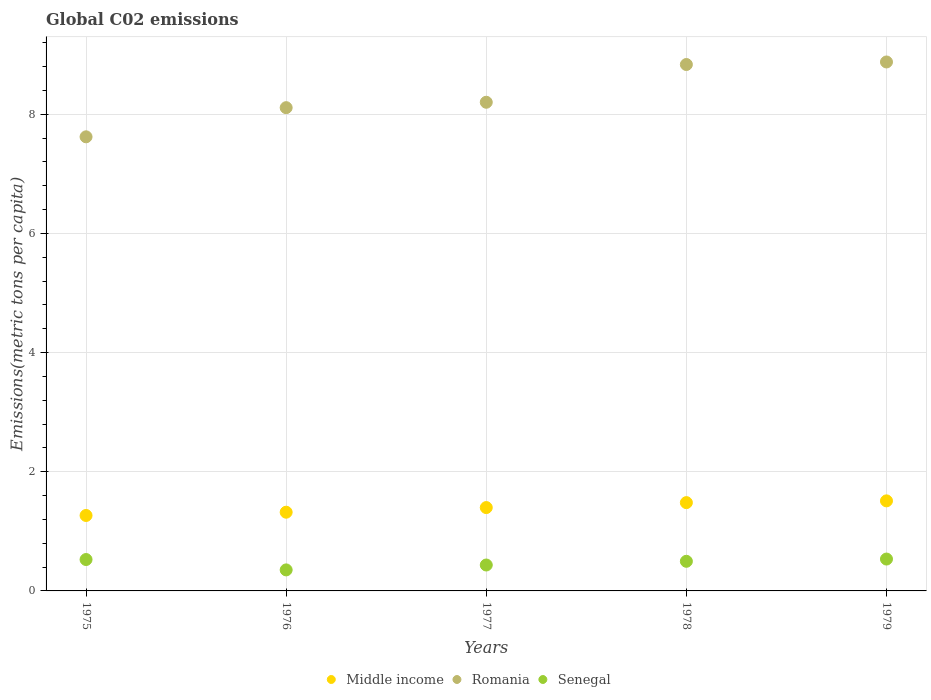How many different coloured dotlines are there?
Ensure brevity in your answer.  3. Is the number of dotlines equal to the number of legend labels?
Ensure brevity in your answer.  Yes. What is the amount of CO2 emitted in in Romania in 1979?
Your response must be concise. 8.88. Across all years, what is the maximum amount of CO2 emitted in in Middle income?
Provide a short and direct response. 1.51. Across all years, what is the minimum amount of CO2 emitted in in Senegal?
Make the answer very short. 0.35. In which year was the amount of CO2 emitted in in Middle income maximum?
Your answer should be compact. 1979. In which year was the amount of CO2 emitted in in Romania minimum?
Your answer should be compact. 1975. What is the total amount of CO2 emitted in in Senegal in the graph?
Provide a short and direct response. 2.35. What is the difference between the amount of CO2 emitted in in Romania in 1976 and that in 1977?
Ensure brevity in your answer.  -0.09. What is the difference between the amount of CO2 emitted in in Romania in 1979 and the amount of CO2 emitted in in Senegal in 1975?
Give a very brief answer. 8.35. What is the average amount of CO2 emitted in in Senegal per year?
Offer a very short reply. 0.47. In the year 1976, what is the difference between the amount of CO2 emitted in in Middle income and amount of CO2 emitted in in Senegal?
Keep it short and to the point. 0.97. What is the ratio of the amount of CO2 emitted in in Middle income in 1975 to that in 1977?
Provide a succinct answer. 0.91. What is the difference between the highest and the second highest amount of CO2 emitted in in Senegal?
Give a very brief answer. 0.01. What is the difference between the highest and the lowest amount of CO2 emitted in in Middle income?
Provide a short and direct response. 0.25. In how many years, is the amount of CO2 emitted in in Romania greater than the average amount of CO2 emitted in in Romania taken over all years?
Your answer should be compact. 2. Is the sum of the amount of CO2 emitted in in Romania in 1975 and 1978 greater than the maximum amount of CO2 emitted in in Senegal across all years?
Keep it short and to the point. Yes. Does the amount of CO2 emitted in in Senegal monotonically increase over the years?
Ensure brevity in your answer.  No. Is the amount of CO2 emitted in in Middle income strictly greater than the amount of CO2 emitted in in Romania over the years?
Ensure brevity in your answer.  No. How many dotlines are there?
Your answer should be very brief. 3. How many years are there in the graph?
Provide a succinct answer. 5. Are the values on the major ticks of Y-axis written in scientific E-notation?
Your answer should be compact. No. How many legend labels are there?
Provide a short and direct response. 3. What is the title of the graph?
Ensure brevity in your answer.  Global C02 emissions. What is the label or title of the X-axis?
Ensure brevity in your answer.  Years. What is the label or title of the Y-axis?
Keep it short and to the point. Emissions(metric tons per capita). What is the Emissions(metric tons per capita) in Middle income in 1975?
Ensure brevity in your answer.  1.27. What is the Emissions(metric tons per capita) of Romania in 1975?
Provide a short and direct response. 7.62. What is the Emissions(metric tons per capita) of Senegal in 1975?
Your answer should be compact. 0.53. What is the Emissions(metric tons per capita) of Middle income in 1976?
Provide a short and direct response. 1.32. What is the Emissions(metric tons per capita) in Romania in 1976?
Offer a very short reply. 8.11. What is the Emissions(metric tons per capita) of Senegal in 1976?
Provide a short and direct response. 0.35. What is the Emissions(metric tons per capita) in Middle income in 1977?
Ensure brevity in your answer.  1.4. What is the Emissions(metric tons per capita) in Romania in 1977?
Provide a succinct answer. 8.2. What is the Emissions(metric tons per capita) in Senegal in 1977?
Make the answer very short. 0.43. What is the Emissions(metric tons per capita) in Middle income in 1978?
Offer a terse response. 1.48. What is the Emissions(metric tons per capita) in Romania in 1978?
Offer a very short reply. 8.83. What is the Emissions(metric tons per capita) in Senegal in 1978?
Offer a very short reply. 0.5. What is the Emissions(metric tons per capita) in Middle income in 1979?
Keep it short and to the point. 1.51. What is the Emissions(metric tons per capita) in Romania in 1979?
Your answer should be compact. 8.88. What is the Emissions(metric tons per capita) of Senegal in 1979?
Your answer should be very brief. 0.53. Across all years, what is the maximum Emissions(metric tons per capita) of Middle income?
Keep it short and to the point. 1.51. Across all years, what is the maximum Emissions(metric tons per capita) of Romania?
Make the answer very short. 8.88. Across all years, what is the maximum Emissions(metric tons per capita) of Senegal?
Make the answer very short. 0.53. Across all years, what is the minimum Emissions(metric tons per capita) in Middle income?
Provide a short and direct response. 1.27. Across all years, what is the minimum Emissions(metric tons per capita) in Romania?
Your response must be concise. 7.62. Across all years, what is the minimum Emissions(metric tons per capita) of Senegal?
Keep it short and to the point. 0.35. What is the total Emissions(metric tons per capita) in Middle income in the graph?
Offer a terse response. 6.98. What is the total Emissions(metric tons per capita) of Romania in the graph?
Provide a succinct answer. 41.64. What is the total Emissions(metric tons per capita) in Senegal in the graph?
Your response must be concise. 2.35. What is the difference between the Emissions(metric tons per capita) in Middle income in 1975 and that in 1976?
Offer a terse response. -0.05. What is the difference between the Emissions(metric tons per capita) of Romania in 1975 and that in 1976?
Provide a succinct answer. -0.49. What is the difference between the Emissions(metric tons per capita) in Senegal in 1975 and that in 1976?
Make the answer very short. 0.17. What is the difference between the Emissions(metric tons per capita) of Middle income in 1975 and that in 1977?
Provide a short and direct response. -0.13. What is the difference between the Emissions(metric tons per capita) in Romania in 1975 and that in 1977?
Offer a very short reply. -0.58. What is the difference between the Emissions(metric tons per capita) in Senegal in 1975 and that in 1977?
Make the answer very short. 0.09. What is the difference between the Emissions(metric tons per capita) in Middle income in 1975 and that in 1978?
Your response must be concise. -0.22. What is the difference between the Emissions(metric tons per capita) of Romania in 1975 and that in 1978?
Keep it short and to the point. -1.21. What is the difference between the Emissions(metric tons per capita) in Senegal in 1975 and that in 1978?
Make the answer very short. 0.03. What is the difference between the Emissions(metric tons per capita) of Middle income in 1975 and that in 1979?
Ensure brevity in your answer.  -0.25. What is the difference between the Emissions(metric tons per capita) of Romania in 1975 and that in 1979?
Offer a terse response. -1.26. What is the difference between the Emissions(metric tons per capita) of Senegal in 1975 and that in 1979?
Your answer should be compact. -0.01. What is the difference between the Emissions(metric tons per capita) in Middle income in 1976 and that in 1977?
Ensure brevity in your answer.  -0.08. What is the difference between the Emissions(metric tons per capita) of Romania in 1976 and that in 1977?
Provide a short and direct response. -0.09. What is the difference between the Emissions(metric tons per capita) in Senegal in 1976 and that in 1977?
Offer a terse response. -0.08. What is the difference between the Emissions(metric tons per capita) in Middle income in 1976 and that in 1978?
Offer a terse response. -0.16. What is the difference between the Emissions(metric tons per capita) in Romania in 1976 and that in 1978?
Offer a terse response. -0.72. What is the difference between the Emissions(metric tons per capita) of Senegal in 1976 and that in 1978?
Your answer should be very brief. -0.14. What is the difference between the Emissions(metric tons per capita) of Middle income in 1976 and that in 1979?
Keep it short and to the point. -0.19. What is the difference between the Emissions(metric tons per capita) of Romania in 1976 and that in 1979?
Ensure brevity in your answer.  -0.77. What is the difference between the Emissions(metric tons per capita) in Senegal in 1976 and that in 1979?
Keep it short and to the point. -0.18. What is the difference between the Emissions(metric tons per capita) of Middle income in 1977 and that in 1978?
Your answer should be very brief. -0.08. What is the difference between the Emissions(metric tons per capita) of Romania in 1977 and that in 1978?
Offer a terse response. -0.63. What is the difference between the Emissions(metric tons per capita) in Senegal in 1977 and that in 1978?
Your answer should be very brief. -0.06. What is the difference between the Emissions(metric tons per capita) in Middle income in 1977 and that in 1979?
Offer a terse response. -0.11. What is the difference between the Emissions(metric tons per capita) in Romania in 1977 and that in 1979?
Make the answer very short. -0.68. What is the difference between the Emissions(metric tons per capita) in Senegal in 1977 and that in 1979?
Offer a very short reply. -0.1. What is the difference between the Emissions(metric tons per capita) of Middle income in 1978 and that in 1979?
Ensure brevity in your answer.  -0.03. What is the difference between the Emissions(metric tons per capita) of Romania in 1978 and that in 1979?
Offer a terse response. -0.04. What is the difference between the Emissions(metric tons per capita) of Senegal in 1978 and that in 1979?
Give a very brief answer. -0.04. What is the difference between the Emissions(metric tons per capita) of Middle income in 1975 and the Emissions(metric tons per capita) of Romania in 1976?
Your answer should be compact. -6.84. What is the difference between the Emissions(metric tons per capita) in Middle income in 1975 and the Emissions(metric tons per capita) in Senegal in 1976?
Provide a short and direct response. 0.91. What is the difference between the Emissions(metric tons per capita) in Romania in 1975 and the Emissions(metric tons per capita) in Senegal in 1976?
Provide a short and direct response. 7.27. What is the difference between the Emissions(metric tons per capita) of Middle income in 1975 and the Emissions(metric tons per capita) of Romania in 1977?
Your answer should be compact. -6.93. What is the difference between the Emissions(metric tons per capita) in Middle income in 1975 and the Emissions(metric tons per capita) in Senegal in 1977?
Ensure brevity in your answer.  0.83. What is the difference between the Emissions(metric tons per capita) in Romania in 1975 and the Emissions(metric tons per capita) in Senegal in 1977?
Offer a very short reply. 7.19. What is the difference between the Emissions(metric tons per capita) of Middle income in 1975 and the Emissions(metric tons per capita) of Romania in 1978?
Your answer should be compact. -7.57. What is the difference between the Emissions(metric tons per capita) of Middle income in 1975 and the Emissions(metric tons per capita) of Senegal in 1978?
Make the answer very short. 0.77. What is the difference between the Emissions(metric tons per capita) in Romania in 1975 and the Emissions(metric tons per capita) in Senegal in 1978?
Your answer should be compact. 7.12. What is the difference between the Emissions(metric tons per capita) in Middle income in 1975 and the Emissions(metric tons per capita) in Romania in 1979?
Keep it short and to the point. -7.61. What is the difference between the Emissions(metric tons per capita) of Middle income in 1975 and the Emissions(metric tons per capita) of Senegal in 1979?
Your response must be concise. 0.73. What is the difference between the Emissions(metric tons per capita) in Romania in 1975 and the Emissions(metric tons per capita) in Senegal in 1979?
Offer a very short reply. 7.09. What is the difference between the Emissions(metric tons per capita) of Middle income in 1976 and the Emissions(metric tons per capita) of Romania in 1977?
Offer a terse response. -6.88. What is the difference between the Emissions(metric tons per capita) in Middle income in 1976 and the Emissions(metric tons per capita) in Senegal in 1977?
Your response must be concise. 0.89. What is the difference between the Emissions(metric tons per capita) of Romania in 1976 and the Emissions(metric tons per capita) of Senegal in 1977?
Ensure brevity in your answer.  7.67. What is the difference between the Emissions(metric tons per capita) of Middle income in 1976 and the Emissions(metric tons per capita) of Romania in 1978?
Offer a terse response. -7.51. What is the difference between the Emissions(metric tons per capita) in Middle income in 1976 and the Emissions(metric tons per capita) in Senegal in 1978?
Give a very brief answer. 0.82. What is the difference between the Emissions(metric tons per capita) of Romania in 1976 and the Emissions(metric tons per capita) of Senegal in 1978?
Offer a very short reply. 7.61. What is the difference between the Emissions(metric tons per capita) of Middle income in 1976 and the Emissions(metric tons per capita) of Romania in 1979?
Your response must be concise. -7.56. What is the difference between the Emissions(metric tons per capita) of Middle income in 1976 and the Emissions(metric tons per capita) of Senegal in 1979?
Your answer should be very brief. 0.79. What is the difference between the Emissions(metric tons per capita) of Romania in 1976 and the Emissions(metric tons per capita) of Senegal in 1979?
Keep it short and to the point. 7.57. What is the difference between the Emissions(metric tons per capita) in Middle income in 1977 and the Emissions(metric tons per capita) in Romania in 1978?
Your answer should be very brief. -7.43. What is the difference between the Emissions(metric tons per capita) in Middle income in 1977 and the Emissions(metric tons per capita) in Senegal in 1978?
Your response must be concise. 0.9. What is the difference between the Emissions(metric tons per capita) of Romania in 1977 and the Emissions(metric tons per capita) of Senegal in 1978?
Your response must be concise. 7.7. What is the difference between the Emissions(metric tons per capita) in Middle income in 1977 and the Emissions(metric tons per capita) in Romania in 1979?
Your answer should be very brief. -7.48. What is the difference between the Emissions(metric tons per capita) of Middle income in 1977 and the Emissions(metric tons per capita) of Senegal in 1979?
Make the answer very short. 0.86. What is the difference between the Emissions(metric tons per capita) in Romania in 1977 and the Emissions(metric tons per capita) in Senegal in 1979?
Provide a succinct answer. 7.67. What is the difference between the Emissions(metric tons per capita) in Middle income in 1978 and the Emissions(metric tons per capita) in Romania in 1979?
Your answer should be very brief. -7.39. What is the difference between the Emissions(metric tons per capita) in Middle income in 1978 and the Emissions(metric tons per capita) in Senegal in 1979?
Provide a succinct answer. 0.95. What is the difference between the Emissions(metric tons per capita) of Romania in 1978 and the Emissions(metric tons per capita) of Senegal in 1979?
Your answer should be compact. 8.3. What is the average Emissions(metric tons per capita) in Middle income per year?
Your answer should be very brief. 1.4. What is the average Emissions(metric tons per capita) of Romania per year?
Ensure brevity in your answer.  8.33. What is the average Emissions(metric tons per capita) in Senegal per year?
Offer a terse response. 0.47. In the year 1975, what is the difference between the Emissions(metric tons per capita) of Middle income and Emissions(metric tons per capita) of Romania?
Provide a succinct answer. -6.35. In the year 1975, what is the difference between the Emissions(metric tons per capita) in Middle income and Emissions(metric tons per capita) in Senegal?
Give a very brief answer. 0.74. In the year 1975, what is the difference between the Emissions(metric tons per capita) of Romania and Emissions(metric tons per capita) of Senegal?
Ensure brevity in your answer.  7.09. In the year 1976, what is the difference between the Emissions(metric tons per capita) of Middle income and Emissions(metric tons per capita) of Romania?
Give a very brief answer. -6.79. In the year 1976, what is the difference between the Emissions(metric tons per capita) in Middle income and Emissions(metric tons per capita) in Senegal?
Your response must be concise. 0.97. In the year 1976, what is the difference between the Emissions(metric tons per capita) in Romania and Emissions(metric tons per capita) in Senegal?
Offer a terse response. 7.76. In the year 1977, what is the difference between the Emissions(metric tons per capita) in Middle income and Emissions(metric tons per capita) in Romania?
Make the answer very short. -6.8. In the year 1977, what is the difference between the Emissions(metric tons per capita) in Middle income and Emissions(metric tons per capita) in Senegal?
Your answer should be very brief. 0.96. In the year 1977, what is the difference between the Emissions(metric tons per capita) of Romania and Emissions(metric tons per capita) of Senegal?
Your answer should be compact. 7.77. In the year 1978, what is the difference between the Emissions(metric tons per capita) of Middle income and Emissions(metric tons per capita) of Romania?
Provide a succinct answer. -7.35. In the year 1978, what is the difference between the Emissions(metric tons per capita) in Middle income and Emissions(metric tons per capita) in Senegal?
Your answer should be compact. 0.98. In the year 1978, what is the difference between the Emissions(metric tons per capita) of Romania and Emissions(metric tons per capita) of Senegal?
Your answer should be compact. 8.34. In the year 1979, what is the difference between the Emissions(metric tons per capita) of Middle income and Emissions(metric tons per capita) of Romania?
Offer a very short reply. -7.36. In the year 1979, what is the difference between the Emissions(metric tons per capita) in Middle income and Emissions(metric tons per capita) in Senegal?
Keep it short and to the point. 0.98. In the year 1979, what is the difference between the Emissions(metric tons per capita) in Romania and Emissions(metric tons per capita) in Senegal?
Your answer should be compact. 8.34. What is the ratio of the Emissions(metric tons per capita) of Middle income in 1975 to that in 1976?
Provide a succinct answer. 0.96. What is the ratio of the Emissions(metric tons per capita) of Romania in 1975 to that in 1976?
Keep it short and to the point. 0.94. What is the ratio of the Emissions(metric tons per capita) of Senegal in 1975 to that in 1976?
Ensure brevity in your answer.  1.49. What is the ratio of the Emissions(metric tons per capita) in Middle income in 1975 to that in 1977?
Keep it short and to the point. 0.91. What is the ratio of the Emissions(metric tons per capita) of Romania in 1975 to that in 1977?
Make the answer very short. 0.93. What is the ratio of the Emissions(metric tons per capita) of Senegal in 1975 to that in 1977?
Give a very brief answer. 1.21. What is the ratio of the Emissions(metric tons per capita) in Middle income in 1975 to that in 1978?
Give a very brief answer. 0.85. What is the ratio of the Emissions(metric tons per capita) in Romania in 1975 to that in 1978?
Give a very brief answer. 0.86. What is the ratio of the Emissions(metric tons per capita) in Senegal in 1975 to that in 1978?
Your response must be concise. 1.06. What is the ratio of the Emissions(metric tons per capita) in Middle income in 1975 to that in 1979?
Ensure brevity in your answer.  0.84. What is the ratio of the Emissions(metric tons per capita) of Romania in 1975 to that in 1979?
Ensure brevity in your answer.  0.86. What is the ratio of the Emissions(metric tons per capita) of Senegal in 1975 to that in 1979?
Offer a very short reply. 0.99. What is the ratio of the Emissions(metric tons per capita) of Middle income in 1976 to that in 1977?
Keep it short and to the point. 0.94. What is the ratio of the Emissions(metric tons per capita) in Romania in 1976 to that in 1977?
Offer a terse response. 0.99. What is the ratio of the Emissions(metric tons per capita) of Senegal in 1976 to that in 1977?
Provide a short and direct response. 0.81. What is the ratio of the Emissions(metric tons per capita) in Middle income in 1976 to that in 1978?
Offer a terse response. 0.89. What is the ratio of the Emissions(metric tons per capita) in Romania in 1976 to that in 1978?
Provide a succinct answer. 0.92. What is the ratio of the Emissions(metric tons per capita) in Senegal in 1976 to that in 1978?
Provide a short and direct response. 0.71. What is the ratio of the Emissions(metric tons per capita) in Middle income in 1976 to that in 1979?
Your answer should be compact. 0.87. What is the ratio of the Emissions(metric tons per capita) in Romania in 1976 to that in 1979?
Give a very brief answer. 0.91. What is the ratio of the Emissions(metric tons per capita) in Senegal in 1976 to that in 1979?
Ensure brevity in your answer.  0.66. What is the ratio of the Emissions(metric tons per capita) of Middle income in 1977 to that in 1978?
Keep it short and to the point. 0.94. What is the ratio of the Emissions(metric tons per capita) in Romania in 1977 to that in 1978?
Provide a short and direct response. 0.93. What is the ratio of the Emissions(metric tons per capita) of Senegal in 1977 to that in 1978?
Make the answer very short. 0.87. What is the ratio of the Emissions(metric tons per capita) in Middle income in 1977 to that in 1979?
Your response must be concise. 0.93. What is the ratio of the Emissions(metric tons per capita) of Romania in 1977 to that in 1979?
Keep it short and to the point. 0.92. What is the ratio of the Emissions(metric tons per capita) in Senegal in 1977 to that in 1979?
Keep it short and to the point. 0.81. What is the ratio of the Emissions(metric tons per capita) in Middle income in 1978 to that in 1979?
Your answer should be compact. 0.98. What is the ratio of the Emissions(metric tons per capita) in Romania in 1978 to that in 1979?
Ensure brevity in your answer.  1. What is the ratio of the Emissions(metric tons per capita) of Senegal in 1978 to that in 1979?
Provide a short and direct response. 0.93. What is the difference between the highest and the second highest Emissions(metric tons per capita) of Middle income?
Your answer should be compact. 0.03. What is the difference between the highest and the second highest Emissions(metric tons per capita) of Romania?
Your answer should be very brief. 0.04. What is the difference between the highest and the second highest Emissions(metric tons per capita) of Senegal?
Provide a short and direct response. 0.01. What is the difference between the highest and the lowest Emissions(metric tons per capita) in Middle income?
Your response must be concise. 0.25. What is the difference between the highest and the lowest Emissions(metric tons per capita) of Romania?
Offer a very short reply. 1.26. What is the difference between the highest and the lowest Emissions(metric tons per capita) of Senegal?
Offer a terse response. 0.18. 